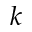Convert formula to latex. <formula><loc_0><loc_0><loc_500><loc_500>k</formula> 